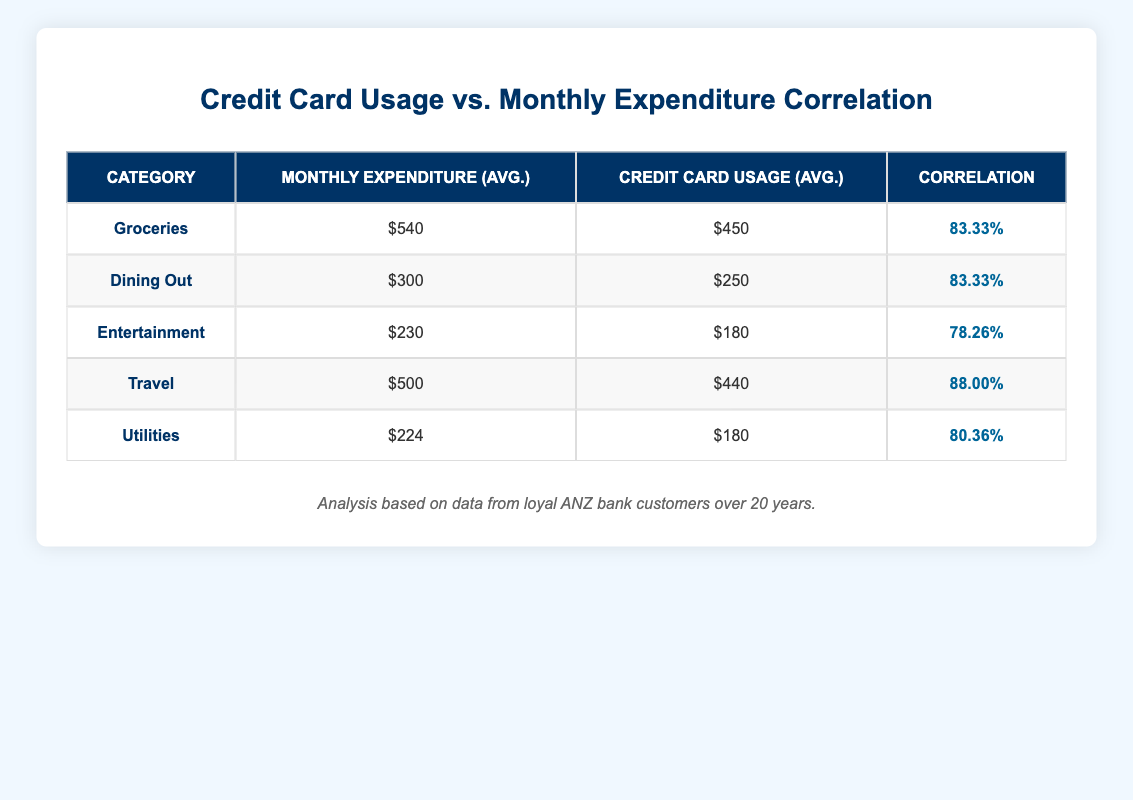What is the average monthly expenditure for dining out? To find the average monthly expenditure for dining out, we look at the "Monthly Expenditure (Avg.)" column for dining out, which shows $300. This is a single value in the table.
Answer: 300 What is the correlation between travel credit card usage and monthly expenditure? From the table, the correlation for the travel category is listed as 88.00%. This tells us how strongly travel credit card usage relates to the monthly expenditure for that category.
Answer: 88.00% Is the average credit card usage for groceries higher than $400? We can see from the table that the average credit card usage for groceries is $450, which is indeed higher than $400.
Answer: Yes What is the difference between average monthly expenditure for entertainment and credit card usage in that category? The average monthly expenditure for entertainment is $230, while the average credit card usage is $180. The difference is calculated by subtracting credit card usage from monthly expenditure: 230 - 180 = 50.
Answer: 50 Which expenditure category has the lowest correlation value? From the correlation values listed in the table, utilities have the lowest correlation at 80.36%. This indicates it has the weakest relationship between credit card usage and monthly spending compared to other categories.
Answer: Utilities 